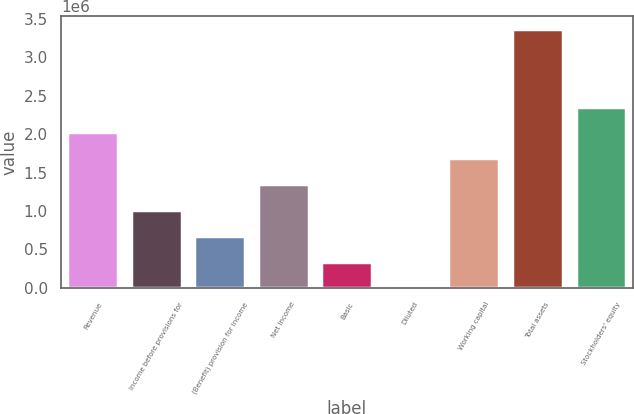Convert chart. <chart><loc_0><loc_0><loc_500><loc_500><bar_chart><fcel>Revenue<fcel>Income before provisions for<fcel>(Benefit) provision for income<fcel>Net income<fcel>Basic<fcel>Diluted<fcel>Working capital<fcel>Total assets<fcel>Stockholders' equity<nl><fcel>2.02131e+06<fcel>1.01065e+06<fcel>673770<fcel>1.34754e+06<fcel>336886<fcel>1.47<fcel>1.68442e+06<fcel>3.36884e+06<fcel>2.35819e+06<nl></chart> 